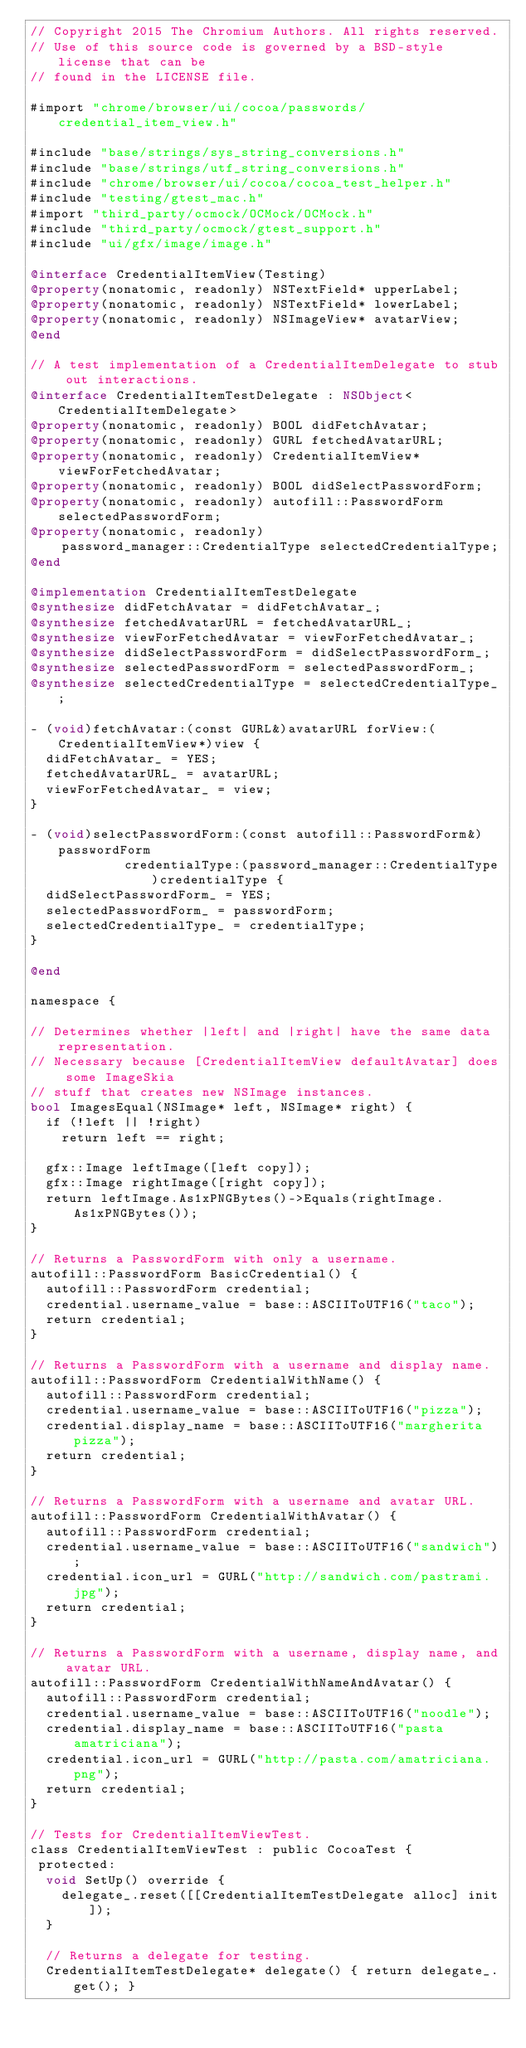Convert code to text. <code><loc_0><loc_0><loc_500><loc_500><_ObjectiveC_>// Copyright 2015 The Chromium Authors. All rights reserved.
// Use of this source code is governed by a BSD-style license that can be
// found in the LICENSE file.

#import "chrome/browser/ui/cocoa/passwords/credential_item_view.h"

#include "base/strings/sys_string_conversions.h"
#include "base/strings/utf_string_conversions.h"
#include "chrome/browser/ui/cocoa/cocoa_test_helper.h"
#include "testing/gtest_mac.h"
#import "third_party/ocmock/OCMock/OCMock.h"
#include "third_party/ocmock/gtest_support.h"
#include "ui/gfx/image/image.h"

@interface CredentialItemView(Testing)
@property(nonatomic, readonly) NSTextField* upperLabel;
@property(nonatomic, readonly) NSTextField* lowerLabel;
@property(nonatomic, readonly) NSImageView* avatarView;
@end

// A test implementation of a CredentialItemDelegate to stub out interactions.
@interface CredentialItemTestDelegate : NSObject<CredentialItemDelegate>
@property(nonatomic, readonly) BOOL didFetchAvatar;
@property(nonatomic, readonly) GURL fetchedAvatarURL;
@property(nonatomic, readonly) CredentialItemView* viewForFetchedAvatar;
@property(nonatomic, readonly) BOOL didSelectPasswordForm;
@property(nonatomic, readonly) autofill::PasswordForm selectedPasswordForm;
@property(nonatomic, readonly)
    password_manager::CredentialType selectedCredentialType;
@end

@implementation CredentialItemTestDelegate
@synthesize didFetchAvatar = didFetchAvatar_;
@synthesize fetchedAvatarURL = fetchedAvatarURL_;
@synthesize viewForFetchedAvatar = viewForFetchedAvatar_;
@synthesize didSelectPasswordForm = didSelectPasswordForm_;
@synthesize selectedPasswordForm = selectedPasswordForm_;
@synthesize selectedCredentialType = selectedCredentialType_;

- (void)fetchAvatar:(const GURL&)avatarURL forView:(CredentialItemView*)view {
  didFetchAvatar_ = YES;
  fetchedAvatarURL_ = avatarURL;
  viewForFetchedAvatar_ = view;
}

- (void)selectPasswordForm:(const autofill::PasswordForm&)passwordForm
            credentialType:(password_manager::CredentialType)credentialType {
  didSelectPasswordForm_ = YES;
  selectedPasswordForm_ = passwordForm;
  selectedCredentialType_ = credentialType;
}

@end

namespace {

// Determines whether |left| and |right| have the same data representation.
// Necessary because [CredentialItemView defaultAvatar] does some ImageSkia
// stuff that creates new NSImage instances.
bool ImagesEqual(NSImage* left, NSImage* right) {
  if (!left || !right)
    return left == right;

  gfx::Image leftImage([left copy]);
  gfx::Image rightImage([right copy]);
  return leftImage.As1xPNGBytes()->Equals(rightImage.As1xPNGBytes());
}

// Returns a PasswordForm with only a username.
autofill::PasswordForm BasicCredential() {
  autofill::PasswordForm credential;
  credential.username_value = base::ASCIIToUTF16("taco");
  return credential;
}

// Returns a PasswordForm with a username and display name.
autofill::PasswordForm CredentialWithName() {
  autofill::PasswordForm credential;
  credential.username_value = base::ASCIIToUTF16("pizza");
  credential.display_name = base::ASCIIToUTF16("margherita pizza");
  return credential;
}

// Returns a PasswordForm with a username and avatar URL.
autofill::PasswordForm CredentialWithAvatar() {
  autofill::PasswordForm credential;
  credential.username_value = base::ASCIIToUTF16("sandwich");
  credential.icon_url = GURL("http://sandwich.com/pastrami.jpg");
  return credential;
}

// Returns a PasswordForm with a username, display name, and avatar URL.
autofill::PasswordForm CredentialWithNameAndAvatar() {
  autofill::PasswordForm credential;
  credential.username_value = base::ASCIIToUTF16("noodle");
  credential.display_name = base::ASCIIToUTF16("pasta amatriciana");
  credential.icon_url = GURL("http://pasta.com/amatriciana.png");
  return credential;
}

// Tests for CredentialItemViewTest.
class CredentialItemViewTest : public CocoaTest {
 protected:
  void SetUp() override {
    delegate_.reset([[CredentialItemTestDelegate alloc] init]);
  }

  // Returns a delegate for testing.
  CredentialItemTestDelegate* delegate() { return delegate_.get(); }
</code> 